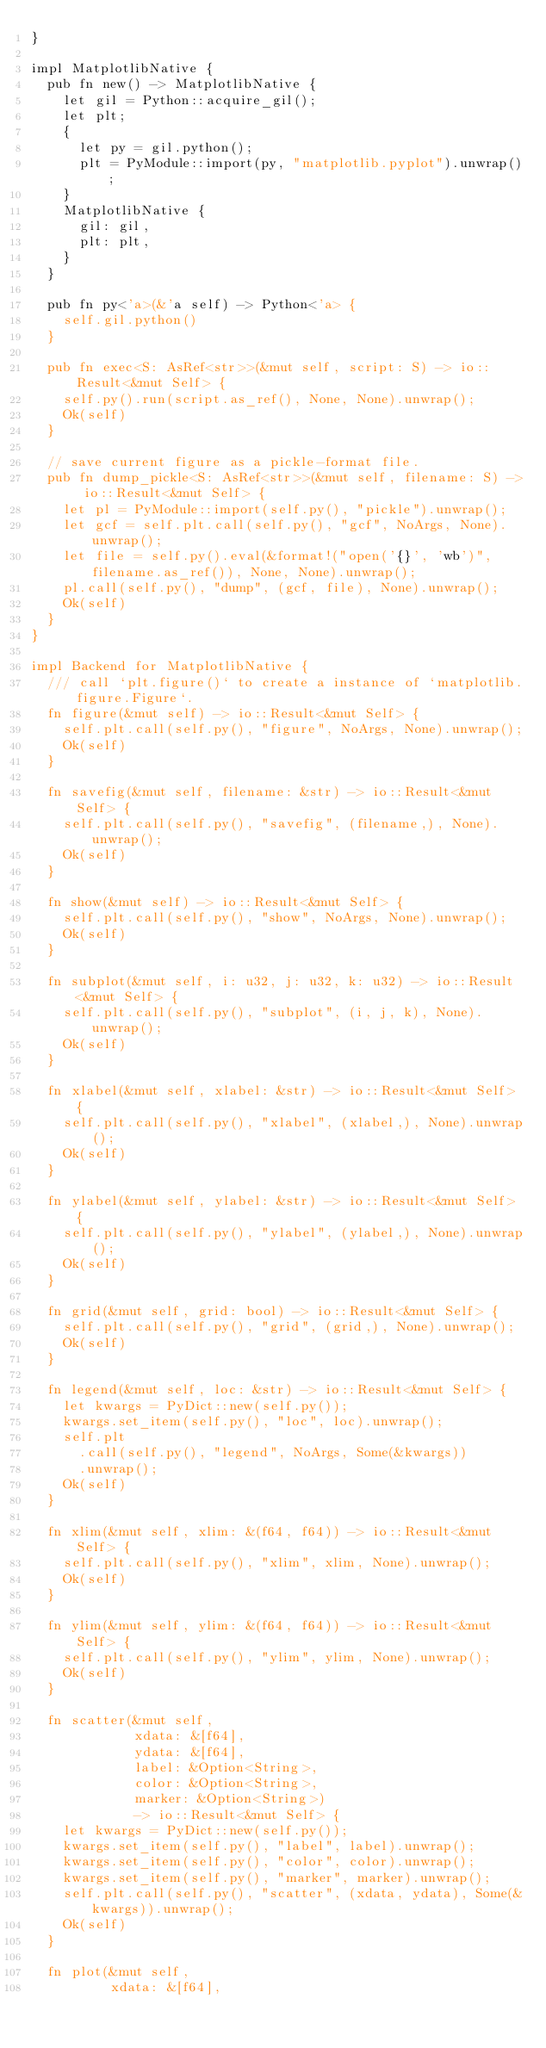Convert code to text. <code><loc_0><loc_0><loc_500><loc_500><_Rust_>}

impl MatplotlibNative {
  pub fn new() -> MatplotlibNative {
    let gil = Python::acquire_gil();
    let plt;
    {
      let py = gil.python();
      plt = PyModule::import(py, "matplotlib.pyplot").unwrap();
    }
    MatplotlibNative {
      gil: gil,
      plt: plt,
    }
  }

  pub fn py<'a>(&'a self) -> Python<'a> {
    self.gil.python()
  }

  pub fn exec<S: AsRef<str>>(&mut self, script: S) -> io::Result<&mut Self> {
    self.py().run(script.as_ref(), None, None).unwrap();
    Ok(self)
  }

  // save current figure as a pickle-format file.
  pub fn dump_pickle<S: AsRef<str>>(&mut self, filename: S) -> io::Result<&mut Self> {
    let pl = PyModule::import(self.py(), "pickle").unwrap();
    let gcf = self.plt.call(self.py(), "gcf", NoArgs, None).unwrap();
    let file = self.py().eval(&format!("open('{}', 'wb')", filename.as_ref()), None, None).unwrap();
    pl.call(self.py(), "dump", (gcf, file), None).unwrap();
    Ok(self)
  }
}

impl Backend for MatplotlibNative {
  /// call `plt.figure()` to create a instance of `matplotlib.figure.Figure`.
  fn figure(&mut self) -> io::Result<&mut Self> {
    self.plt.call(self.py(), "figure", NoArgs, None).unwrap();
    Ok(self)
  }

  fn savefig(&mut self, filename: &str) -> io::Result<&mut Self> {
    self.plt.call(self.py(), "savefig", (filename,), None).unwrap();
    Ok(self)
  }

  fn show(&mut self) -> io::Result<&mut Self> {
    self.plt.call(self.py(), "show", NoArgs, None).unwrap();
    Ok(self)
  }

  fn subplot(&mut self, i: u32, j: u32, k: u32) -> io::Result<&mut Self> {
    self.plt.call(self.py(), "subplot", (i, j, k), None).unwrap();
    Ok(self)
  }

  fn xlabel(&mut self, xlabel: &str) -> io::Result<&mut Self> {
    self.plt.call(self.py(), "xlabel", (xlabel,), None).unwrap();
    Ok(self)
  }

  fn ylabel(&mut self, ylabel: &str) -> io::Result<&mut Self> {
    self.plt.call(self.py(), "ylabel", (ylabel,), None).unwrap();
    Ok(self)
  }

  fn grid(&mut self, grid: bool) -> io::Result<&mut Self> {
    self.plt.call(self.py(), "grid", (grid,), None).unwrap();
    Ok(self)
  }

  fn legend(&mut self, loc: &str) -> io::Result<&mut Self> {
    let kwargs = PyDict::new(self.py());
    kwargs.set_item(self.py(), "loc", loc).unwrap();
    self.plt
      .call(self.py(), "legend", NoArgs, Some(&kwargs))
      .unwrap();
    Ok(self)
  }

  fn xlim(&mut self, xlim: &(f64, f64)) -> io::Result<&mut Self> {
    self.plt.call(self.py(), "xlim", xlim, None).unwrap();
    Ok(self)
  }

  fn ylim(&mut self, ylim: &(f64, f64)) -> io::Result<&mut Self> {
    self.plt.call(self.py(), "ylim", ylim, None).unwrap();
    Ok(self)
  }

  fn scatter(&mut self,
             xdata: &[f64],
             ydata: &[f64],
             label: &Option<String>,
             color: &Option<String>,
             marker: &Option<String>)
             -> io::Result<&mut Self> {
    let kwargs = PyDict::new(self.py());
    kwargs.set_item(self.py(), "label", label).unwrap();
    kwargs.set_item(self.py(), "color", color).unwrap();
    kwargs.set_item(self.py(), "marker", marker).unwrap();
    self.plt.call(self.py(), "scatter", (xdata, ydata), Some(&kwargs)).unwrap();
    Ok(self)
  }

  fn plot(&mut self,
          xdata: &[f64],</code> 